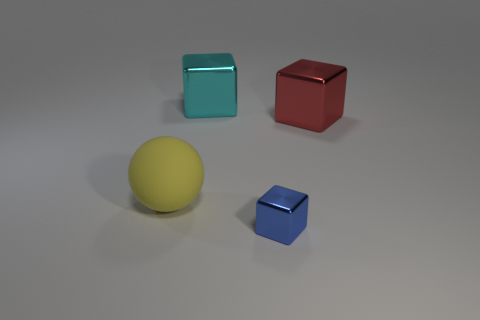Add 4 big gray matte spheres. How many objects exist? 8 Subtract all spheres. How many objects are left? 3 Subtract 1 red blocks. How many objects are left? 3 Subtract all tiny red metallic cubes. Subtract all cyan cubes. How many objects are left? 3 Add 4 large red metallic cubes. How many large red metallic cubes are left? 5 Add 1 large red objects. How many large red objects exist? 2 